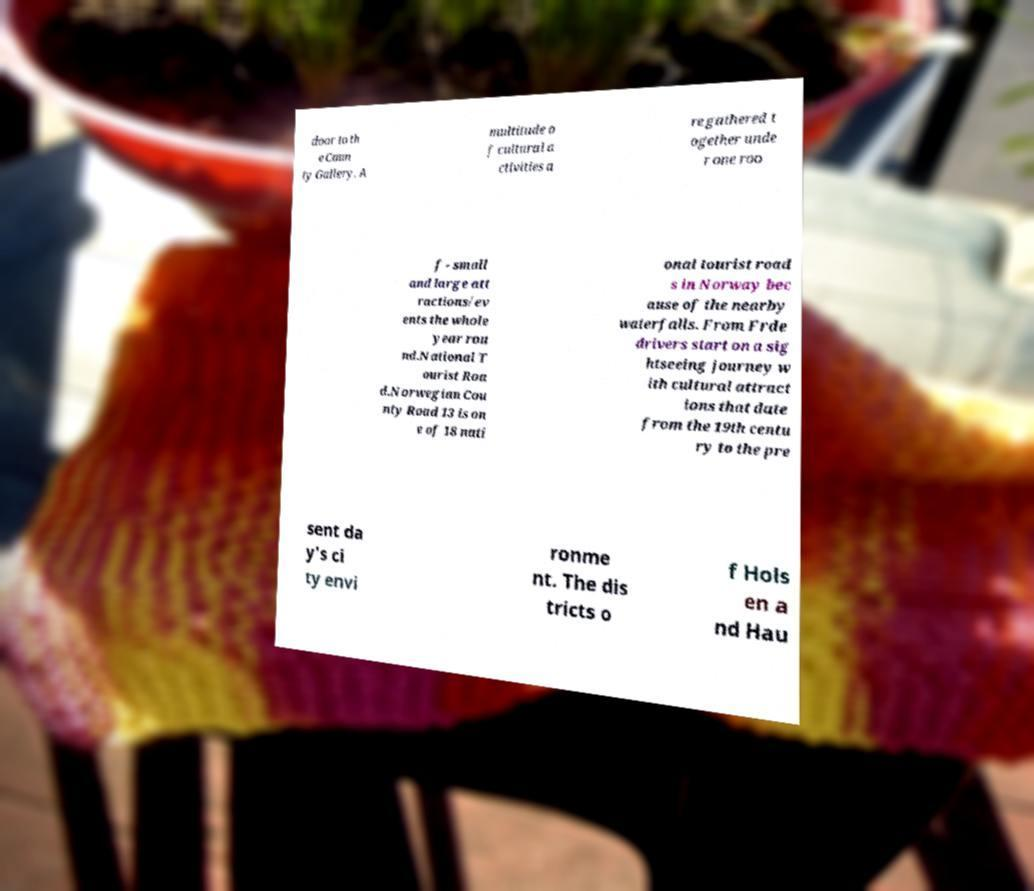What messages or text are displayed in this image? I need them in a readable, typed format. door to th e Coun ty Gallery. A multitude o f cultural a ctivities a re gathered t ogether unde r one roo f - small and large att ractions/ev ents the whole year rou nd.National T ourist Roa d.Norwegian Cou nty Road 13 is on e of 18 nati onal tourist road s in Norway bec ause of the nearby waterfalls. From Frde drivers start on a sig htseeing journey w ith cultural attract ions that date from the 19th centu ry to the pre sent da y's ci ty envi ronme nt. The dis tricts o f Hols en a nd Hau 